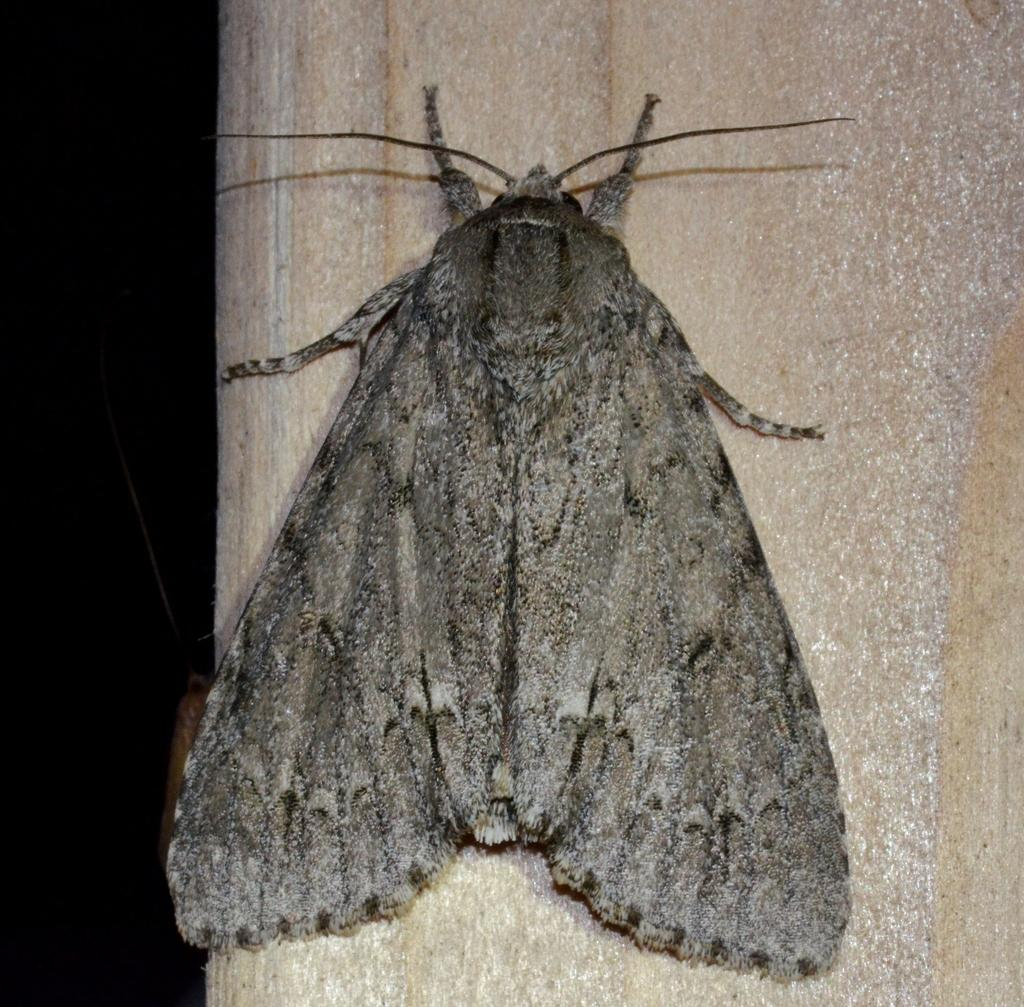What is the main subject in the center of the image? There is an insect in the center of the image. Where is the insect located? The insect is on a wall. What can be seen in the background of the image? There are objects visible in the background of the image. How many legs does the squirrel have in the image? There is no squirrel present in the image; it features an insect on a wall. 